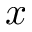<formula> <loc_0><loc_0><loc_500><loc_500>x</formula> 